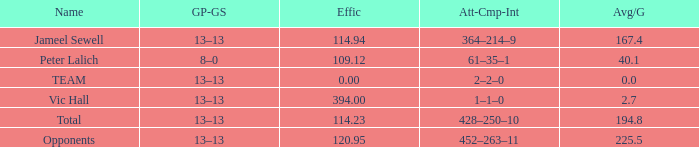What efficiency corresponds to an avg/g of 394.0. 